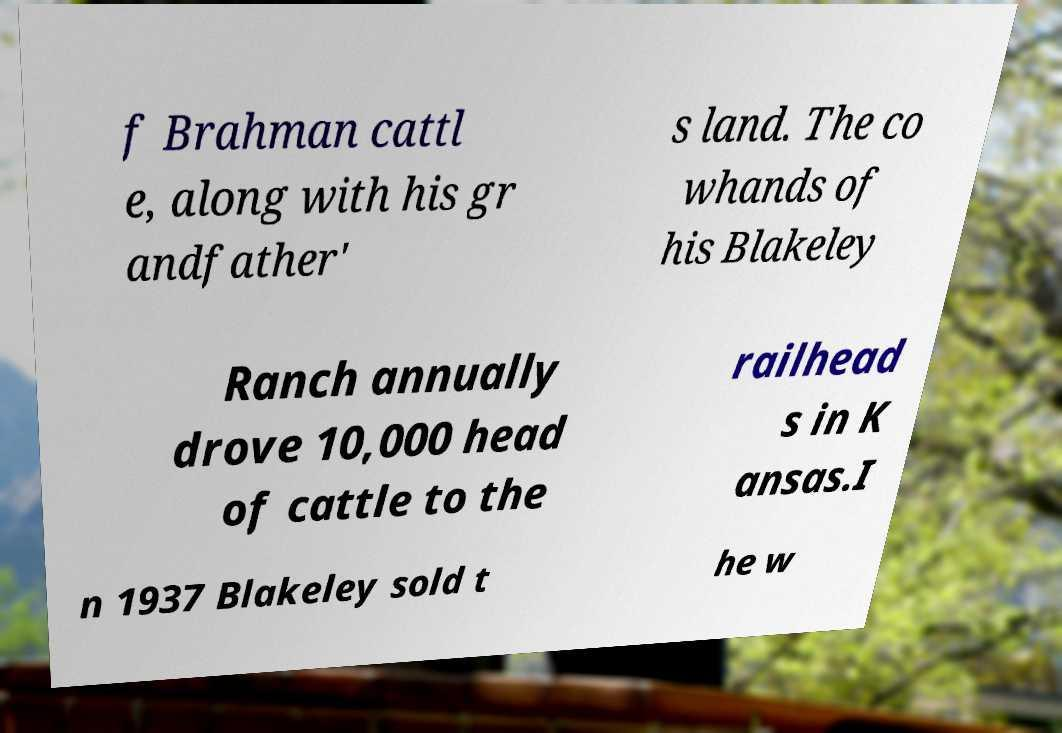There's text embedded in this image that I need extracted. Can you transcribe it verbatim? f Brahman cattl e, along with his gr andfather' s land. The co whands of his Blakeley Ranch annually drove 10,000 head of cattle to the railhead s in K ansas.I n 1937 Blakeley sold t he w 